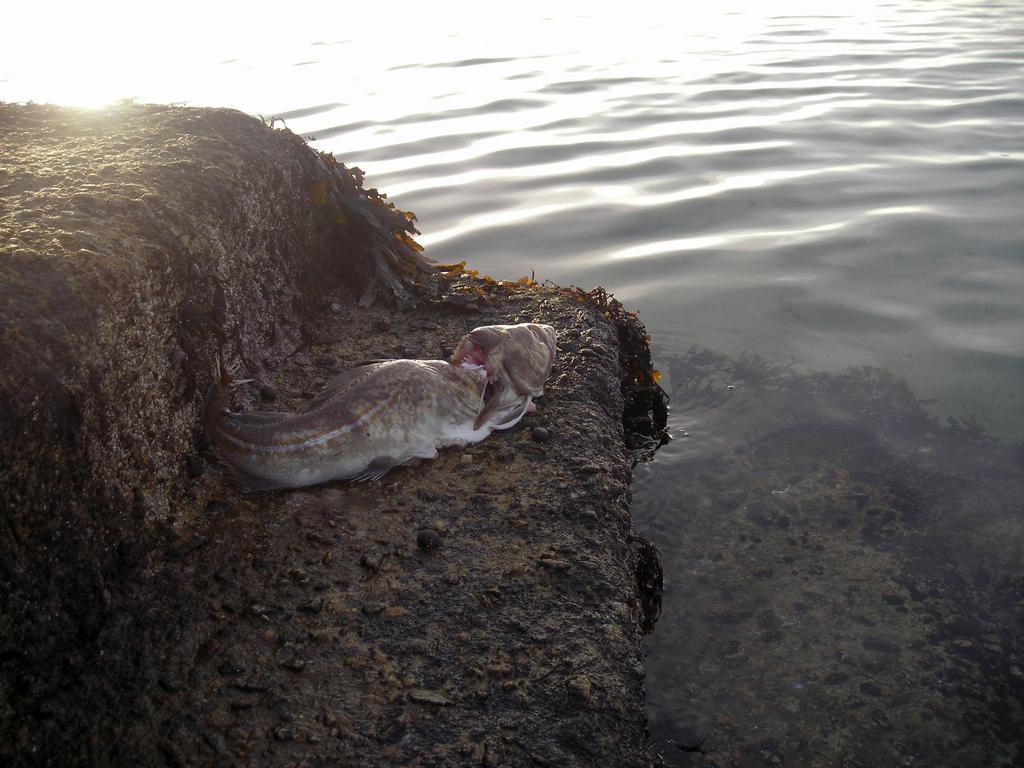Please provide a concise description of this image. In the image we can see a fish out of the water, this is a stone and water. 